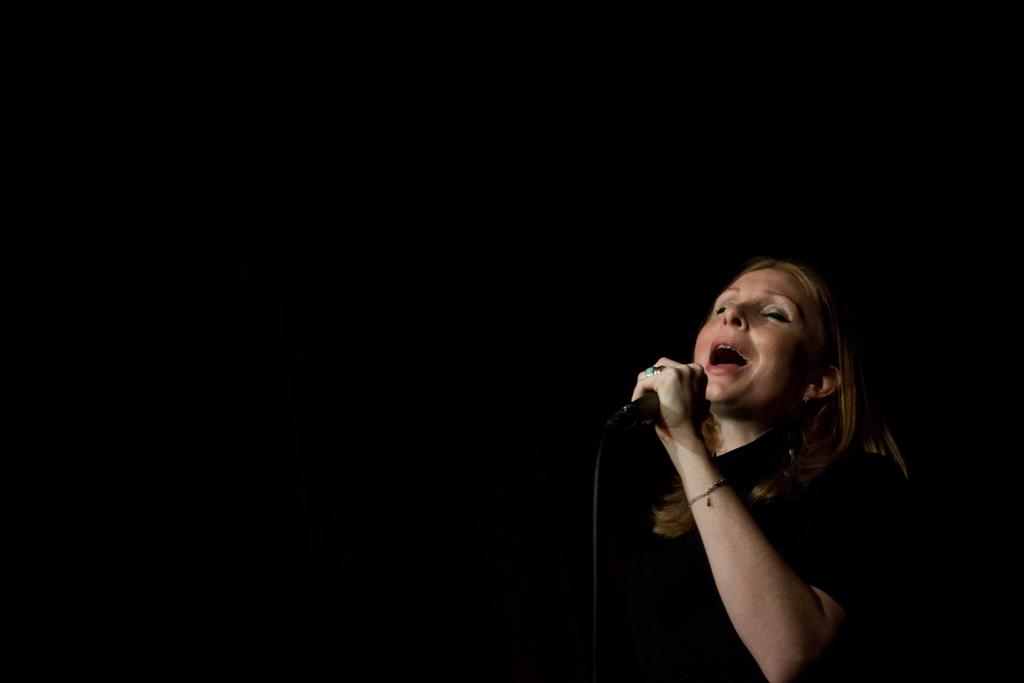Who is the main subject in the image? There is a woman in the image. What is the woman holding in the image? The woman is holding a mic. What is the woman doing in the image? The woman is singing. What is the color of the background in the image? The background of the image is dark. What type of eggs can be seen cooking on the stove in the image? There is no stove or eggs present in the image; it features a woman holding a mic and singing. What is the weight of the woman in the image? The weight of the woman cannot be determined from the image. 